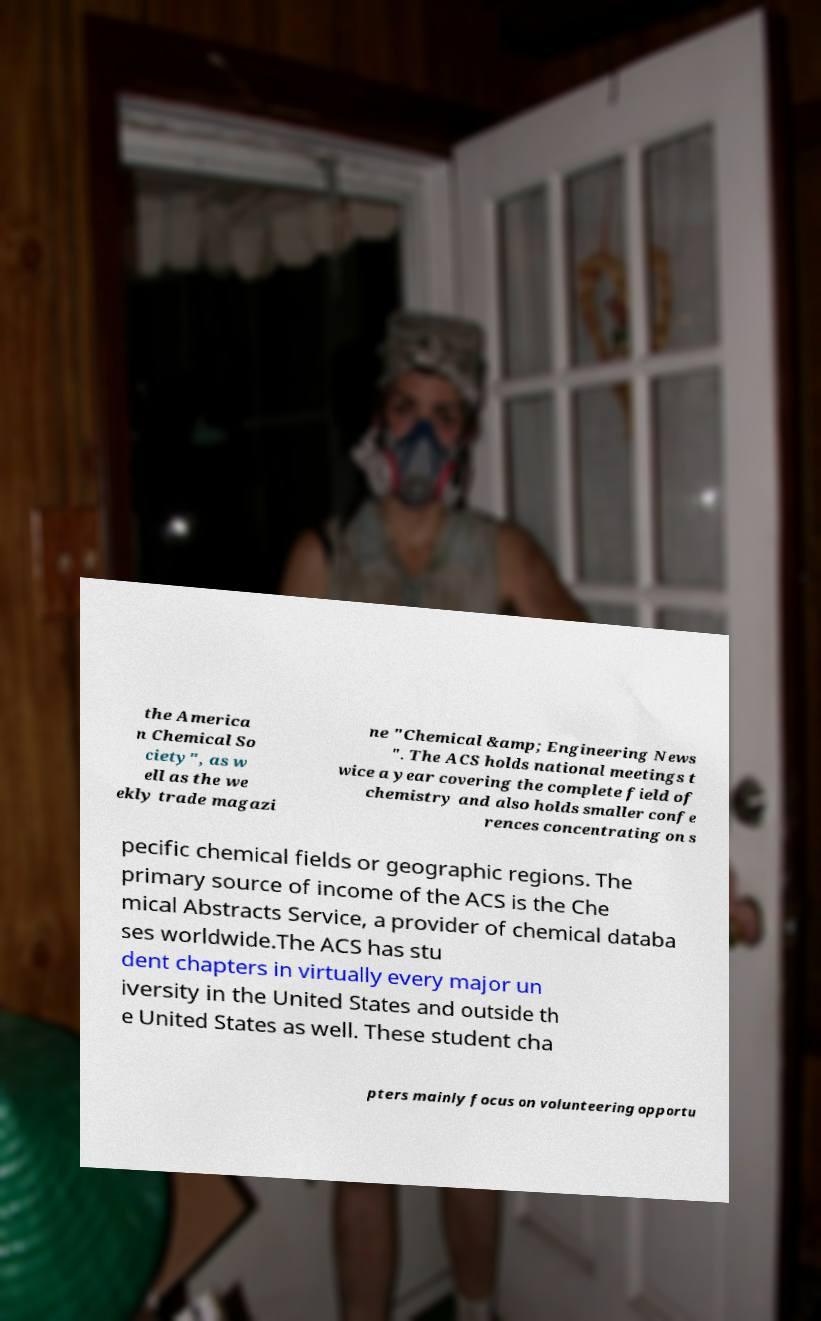Can you accurately transcribe the text from the provided image for me? the America n Chemical So ciety", as w ell as the we ekly trade magazi ne "Chemical &amp; Engineering News ". The ACS holds national meetings t wice a year covering the complete field of chemistry and also holds smaller confe rences concentrating on s pecific chemical fields or geographic regions. The primary source of income of the ACS is the Che mical Abstracts Service, a provider of chemical databa ses worldwide.The ACS has stu dent chapters in virtually every major un iversity in the United States and outside th e United States as well. These student cha pters mainly focus on volunteering opportu 